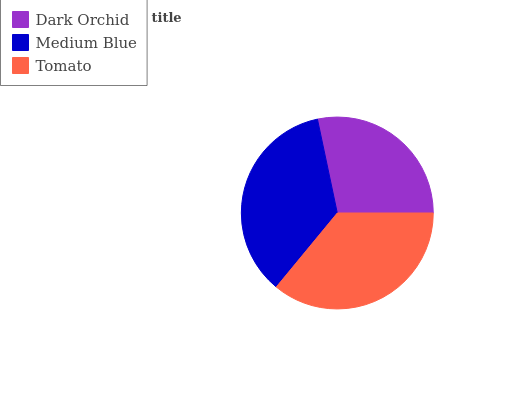Is Dark Orchid the minimum?
Answer yes or no. Yes. Is Tomato the maximum?
Answer yes or no. Yes. Is Medium Blue the minimum?
Answer yes or no. No. Is Medium Blue the maximum?
Answer yes or no. No. Is Medium Blue greater than Dark Orchid?
Answer yes or no. Yes. Is Dark Orchid less than Medium Blue?
Answer yes or no. Yes. Is Dark Orchid greater than Medium Blue?
Answer yes or no. No. Is Medium Blue less than Dark Orchid?
Answer yes or no. No. Is Medium Blue the high median?
Answer yes or no. Yes. Is Medium Blue the low median?
Answer yes or no. Yes. Is Tomato the high median?
Answer yes or no. No. Is Dark Orchid the low median?
Answer yes or no. No. 